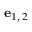<formula> <loc_0><loc_0><loc_500><loc_500>e _ { 1 , \, 2 }</formula> 